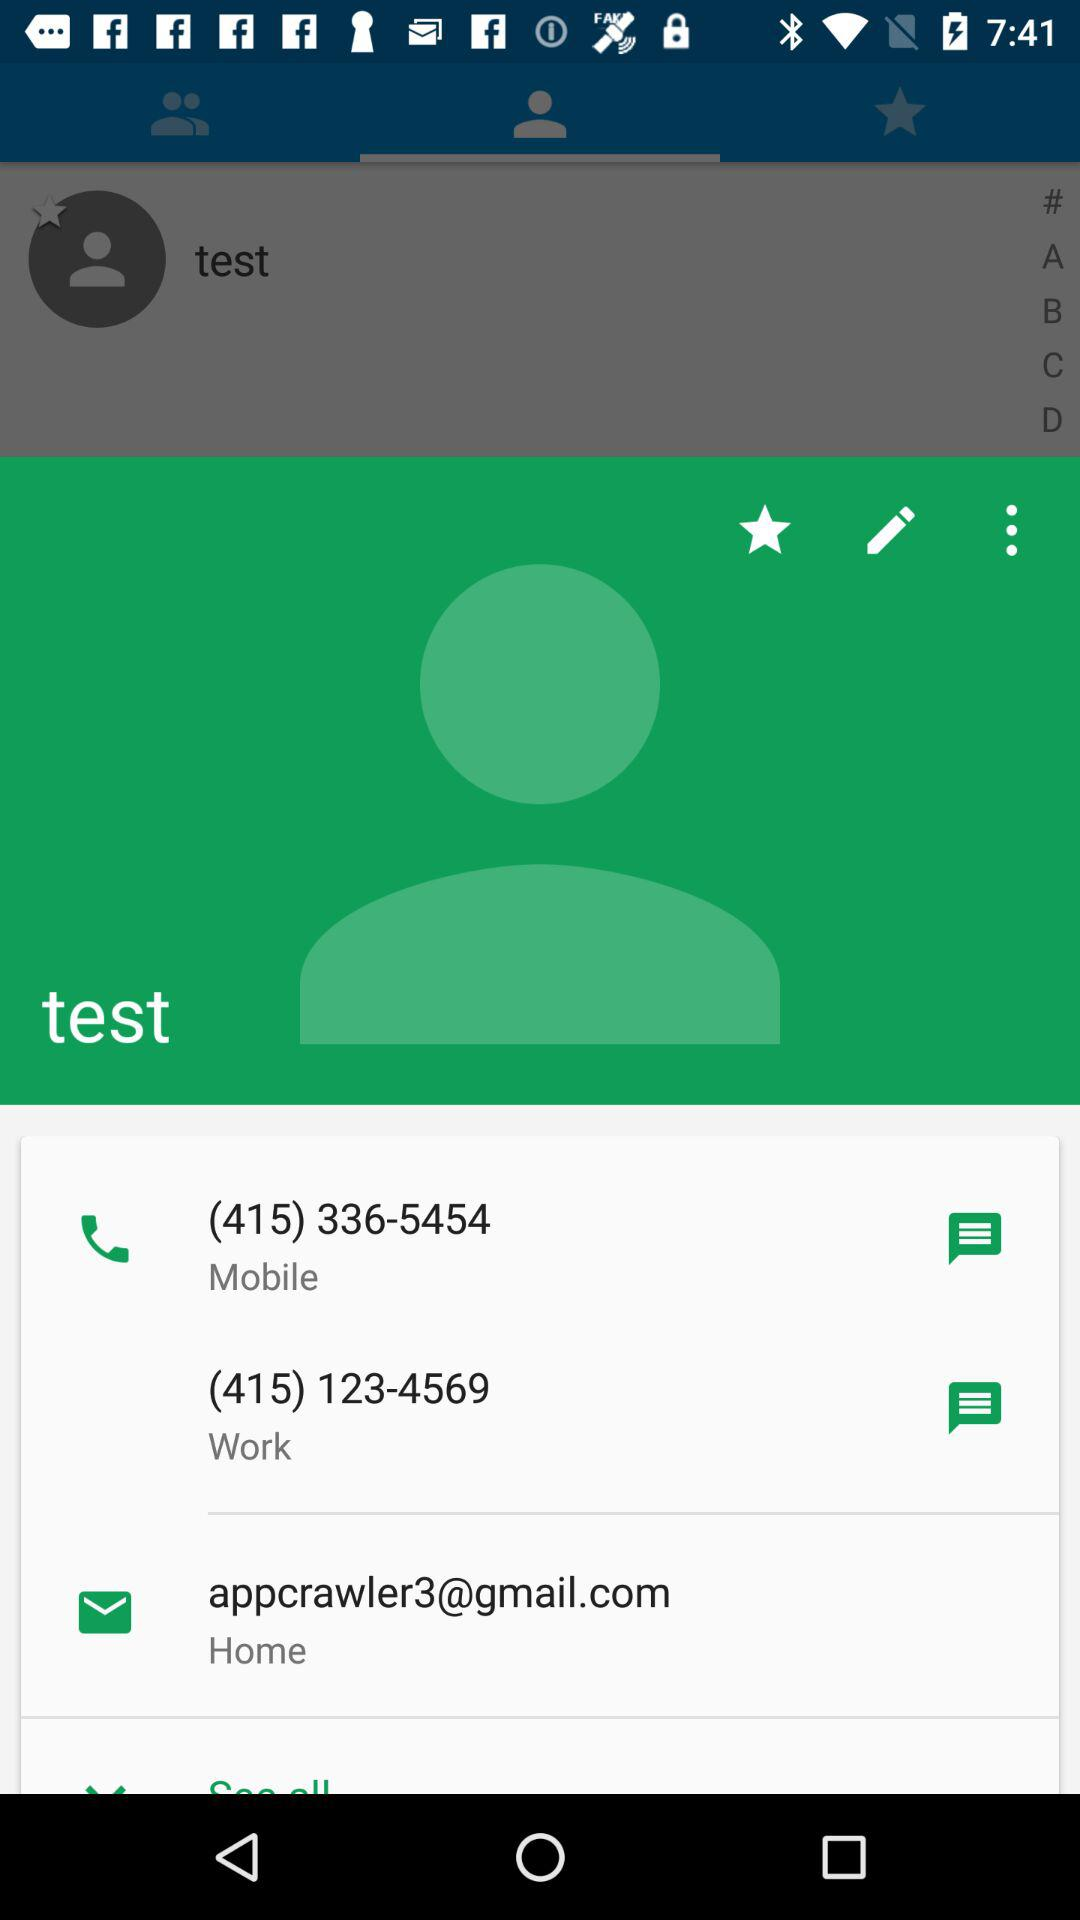What is the work phone number? The work phone number is (415) 123-4569. 